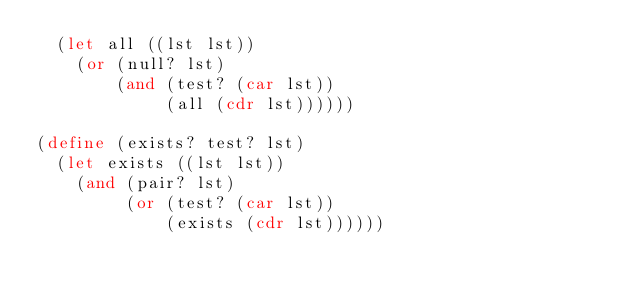<code> <loc_0><loc_0><loc_500><loc_500><_Scheme_>  (let all ((lst lst))
    (or (null? lst)
        (and (test? (car lst))
             (all (cdr lst))))))

(define (exists? test? lst)
  (let exists ((lst lst))
    (and (pair? lst)
         (or (test? (car lst))
             (exists (cdr lst))))))

</code> 